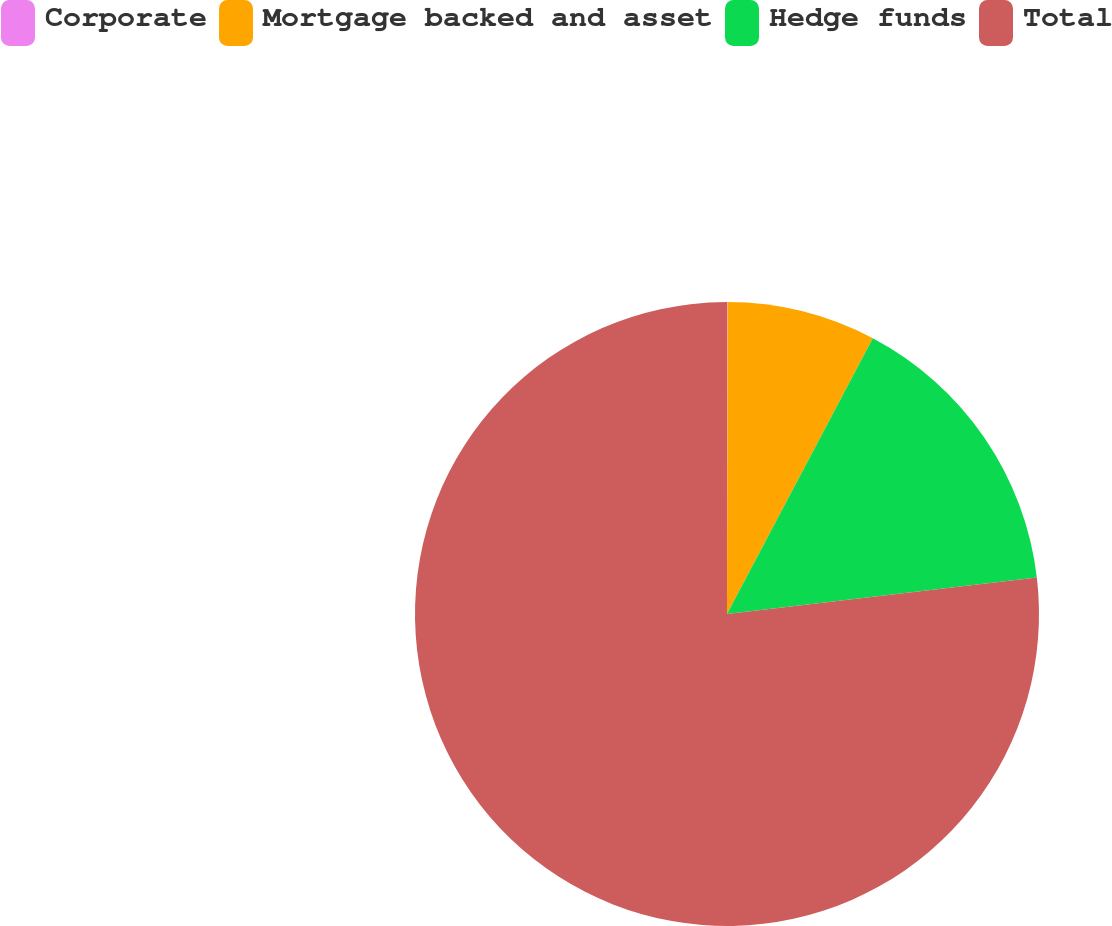Convert chart. <chart><loc_0><loc_0><loc_500><loc_500><pie_chart><fcel>Corporate<fcel>Mortgage backed and asset<fcel>Hedge funds<fcel>Total<nl><fcel>0.03%<fcel>7.71%<fcel>15.4%<fcel>76.86%<nl></chart> 